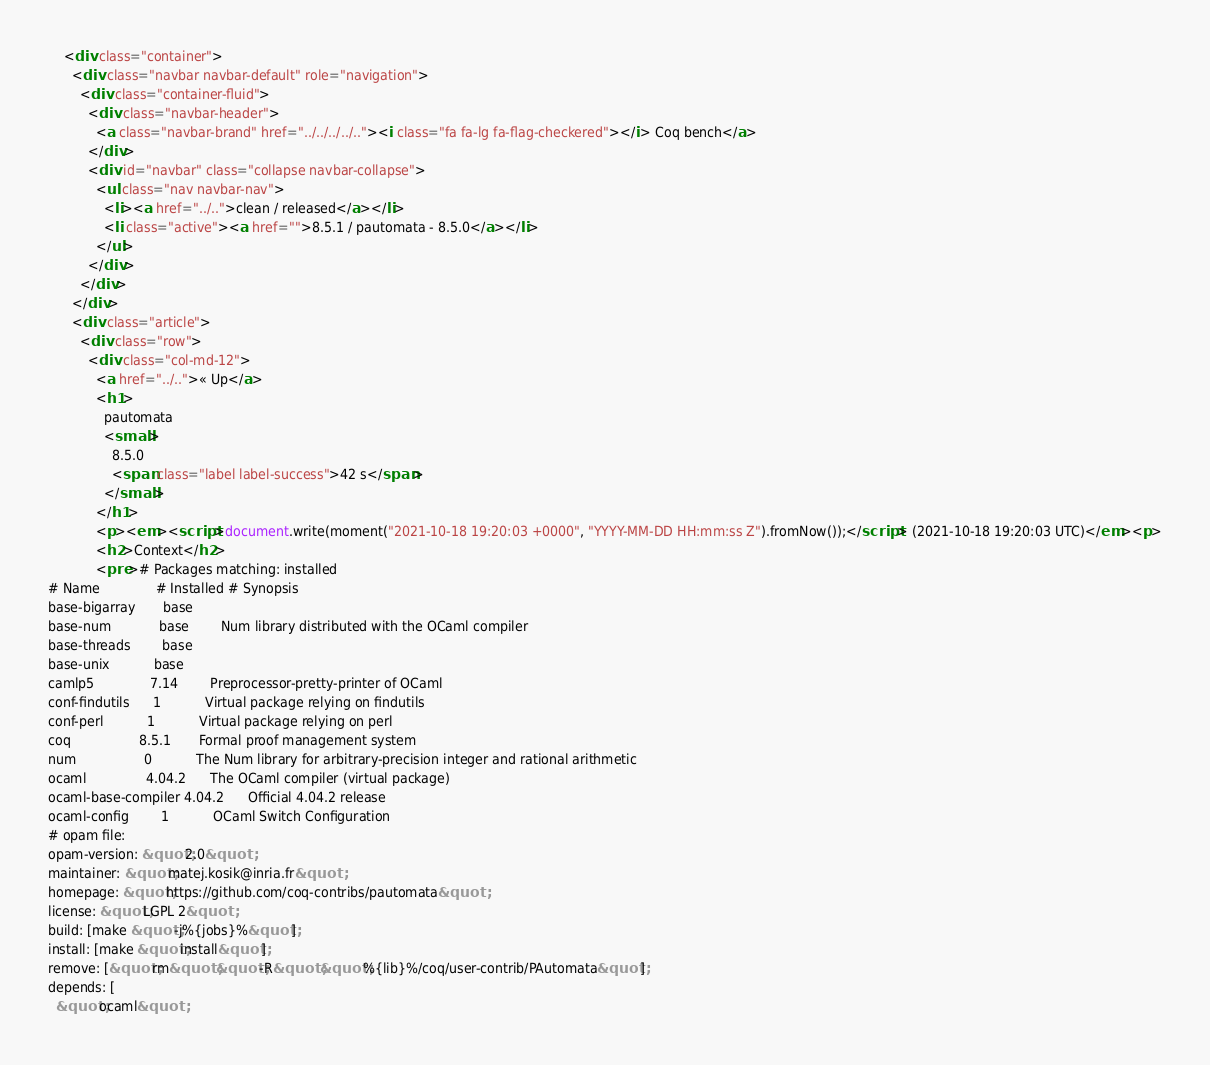Convert code to text. <code><loc_0><loc_0><loc_500><loc_500><_HTML_>    <div class="container">
      <div class="navbar navbar-default" role="navigation">
        <div class="container-fluid">
          <div class="navbar-header">
            <a class="navbar-brand" href="../../../../.."><i class="fa fa-lg fa-flag-checkered"></i> Coq bench</a>
          </div>
          <div id="navbar" class="collapse navbar-collapse">
            <ul class="nav navbar-nav">
              <li><a href="../..">clean / released</a></li>
              <li class="active"><a href="">8.5.1 / pautomata - 8.5.0</a></li>
            </ul>
          </div>
        </div>
      </div>
      <div class="article">
        <div class="row">
          <div class="col-md-12">
            <a href="../..">« Up</a>
            <h1>
              pautomata
              <small>
                8.5.0
                <span class="label label-success">42 s</span>
              </small>
            </h1>
            <p><em><script>document.write(moment("2021-10-18 19:20:03 +0000", "YYYY-MM-DD HH:mm:ss Z").fromNow());</script> (2021-10-18 19:20:03 UTC)</em><p>
            <h2>Context</h2>
            <pre># Packages matching: installed
# Name              # Installed # Synopsis
base-bigarray       base
base-num            base        Num library distributed with the OCaml compiler
base-threads        base
base-unix           base
camlp5              7.14        Preprocessor-pretty-printer of OCaml
conf-findutils      1           Virtual package relying on findutils
conf-perl           1           Virtual package relying on perl
coq                 8.5.1       Formal proof management system
num                 0           The Num library for arbitrary-precision integer and rational arithmetic
ocaml               4.04.2      The OCaml compiler (virtual package)
ocaml-base-compiler 4.04.2      Official 4.04.2 release
ocaml-config        1           OCaml Switch Configuration
# opam file:
opam-version: &quot;2.0&quot;
maintainer: &quot;matej.kosik@inria.fr&quot;
homepage: &quot;https://github.com/coq-contribs/pautomata&quot;
license: &quot;LGPL 2&quot;
build: [make &quot;-j%{jobs}%&quot;]
install: [make &quot;install&quot;]
remove: [&quot;rm&quot; &quot;-R&quot; &quot;%{lib}%/coq/user-contrib/PAutomata&quot;]
depends: [
  &quot;ocaml&quot;</code> 